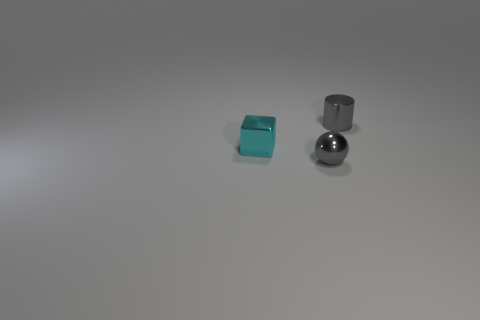Add 2 small gray shiny spheres. How many objects exist? 5 Subtract all balls. How many objects are left? 2 Add 1 small balls. How many small balls exist? 2 Subtract 0 red cubes. How many objects are left? 3 Subtract all tiny red things. Subtract all small gray metallic objects. How many objects are left? 1 Add 2 tiny cyan metallic things. How many tiny cyan metallic things are left? 3 